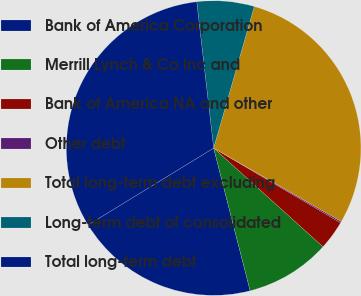Convert chart to OTSL. <chart><loc_0><loc_0><loc_500><loc_500><pie_chart><fcel>Bank of America Corporation<fcel>Merrill Lynch & Co Inc and<fcel>Bank of America NA and other<fcel>Other debt<fcel>Total long-term debt excluding<fcel>Long-term debt of consolidated<fcel>Total long-term debt<nl><fcel>20.24%<fcel>9.33%<fcel>3.22%<fcel>0.16%<fcel>28.86%<fcel>6.28%<fcel>31.91%<nl></chart> 